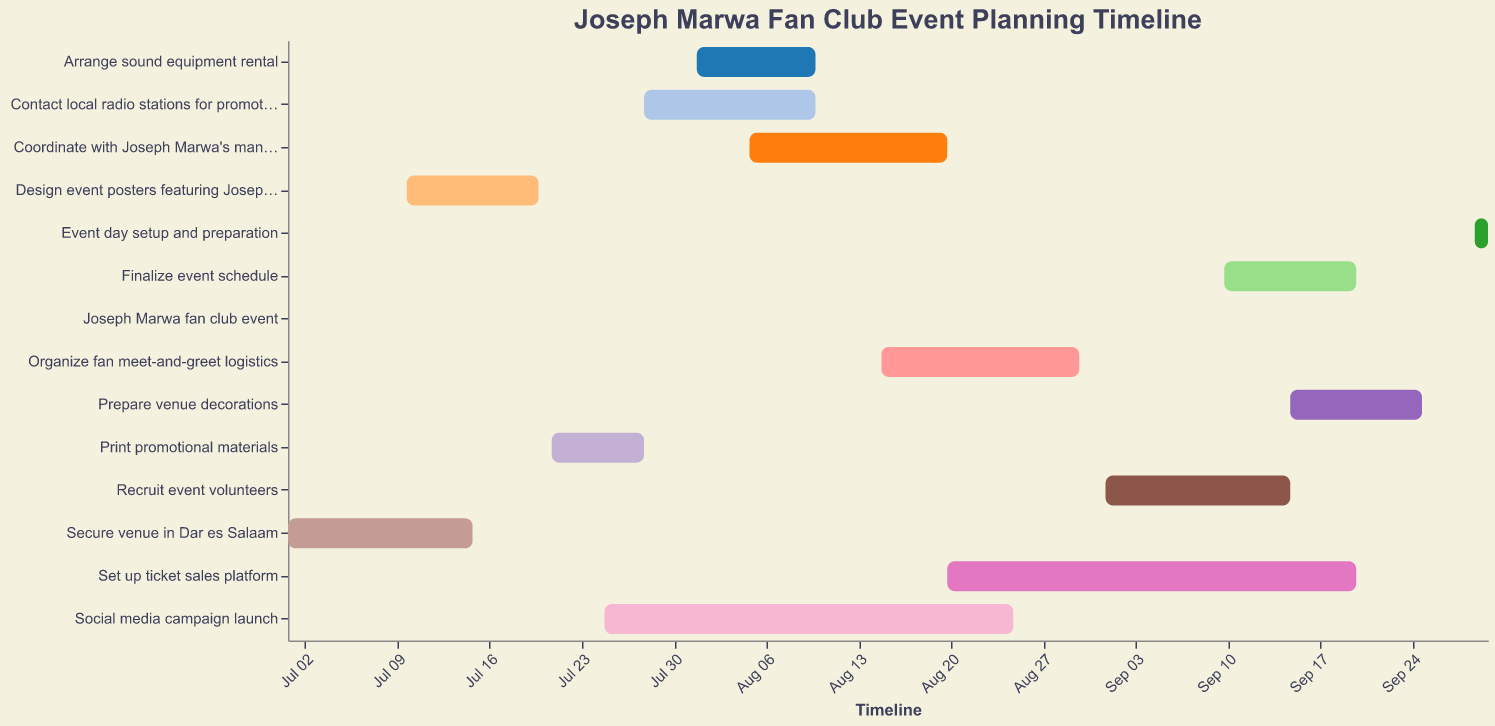What is the title of the Gantt chart? The title is located at the top of the Gantt chart and is typically displayed prominently. The title of the Gantt chart is "Joseph Marwa Fan Club Event Planning Timeline".
Answer: Joseph Marwa Fan Club Event Planning Timeline When does the task "Secure venue in Dar es Salaam" start and end? Looking at the Gantt chart, the start date and end date for each task are plotted along the timeline. The task "Secure venue in Dar es Salaam" starts on July 1, 2023, and ends on July 15, 2023.
Answer: July 1, 2023, and July 15, 2023 Which tasks are ongoing during the entire month of August? To find the answer, identify the tasks whose start and end dates encompass the entire month of August on the timeline. These tasks are "Social media campaign launch" (July 25 - August 25) and "Set up ticket sales platform" (August 20 - September 20).
Answer: Social media campaign launch What tasks overlap with "Design event posters featuring Joseph Marwa"? Check the timeline for the task "Design event posters featuring Joseph Marwa" (July 10 - July 20) and see which other tasks are ongoing during this period. The tasks "Secure venue in Dar es Salaam" (until July 15) and "Print promotional materials" (starting July 21) overlap with it.
Answer: Secure venue in Dar es Salaam Which task has the shortest duration? To determine the shortest duration, compare the number of days for each task by looking at their start and end dates. The task "Joseph Marwa fan club event" has the shortest duration as it is only on September 30, 2023.
Answer: Joseph Marwa fan club event What is the total duration (in days) of "Organize fan meet-and-greet logistics"? To calculate the total duration of this task, find the difference between the start and end dates: August 15, 2023, to August 30, 2023. The total duration is 15 days.
Answer: 15 days When does the latest task begin and end? Identify the task with the latest start date on the Gantt chart. The task "Event day setup and preparation" starts on September 29, 2023, and ends on September 30, 2023.
Answer: September 29, 2023, and September 30, 2023 How many tasks have start dates in July? To answer this, count the number of tasks that begin within the month of July. The tasks are "Secure venue in Dar es Salaam," "Design event posters featuring Joseph Marwa," "Print promotional materials," "Social media campaign launch," and "Contact local radio stations for promotion." There are 5 tasks in total.
Answer: 5 tasks Which tasks need to be completed before coordinating with Joseph Marwa's management begins? Look at the Gantt chart to find the tasks that end before "Coordinate with Joseph Marwa's management" starts on August 5, 2023. The tasks are "Secure venue in Dar es Salaam," "Design event posters featuring Joseph Marwa," "Print promotional materials," "Social media campaign launch," "Contact local radio stations for promotion," and "Arrange sound equipment rental."
Answer: 6 tasks 